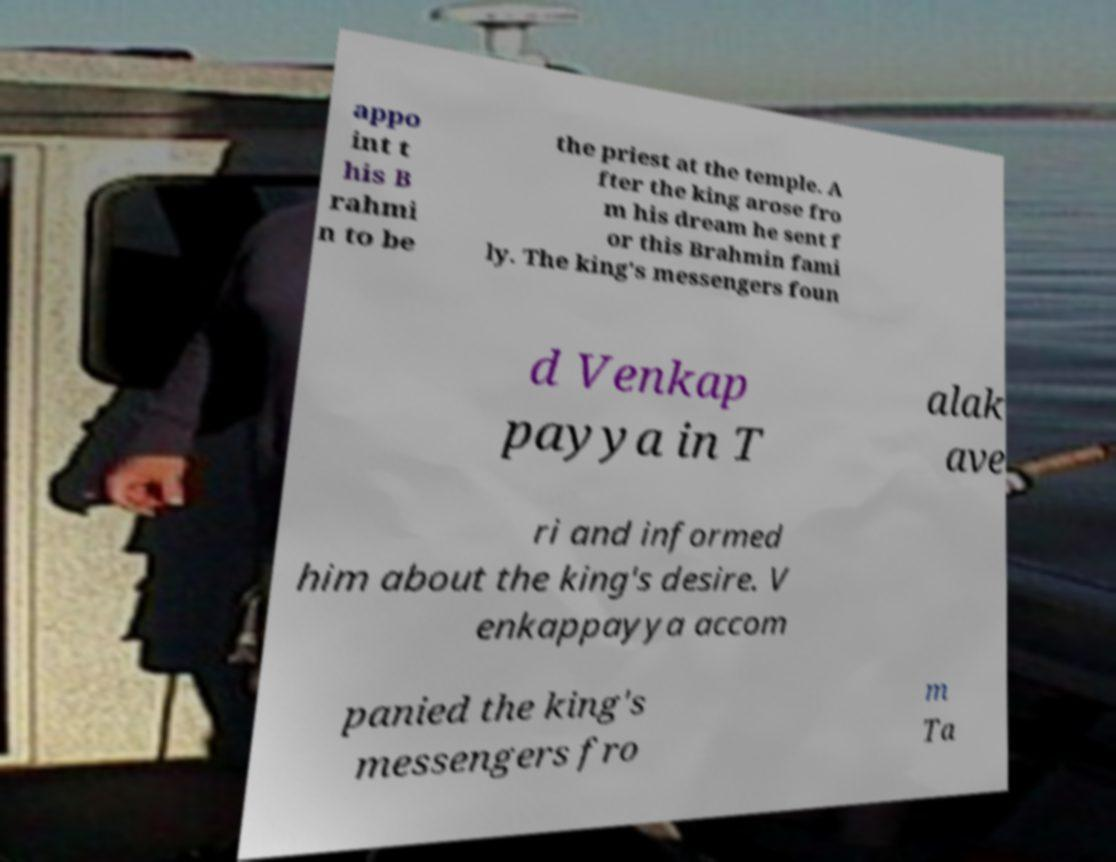Please identify and transcribe the text found in this image. appo int t his B rahmi n to be the priest at the temple. A fter the king arose fro m his dream he sent f or this Brahmin fami ly. The king's messengers foun d Venkap payya in T alak ave ri and informed him about the king's desire. V enkappayya accom panied the king's messengers fro m Ta 